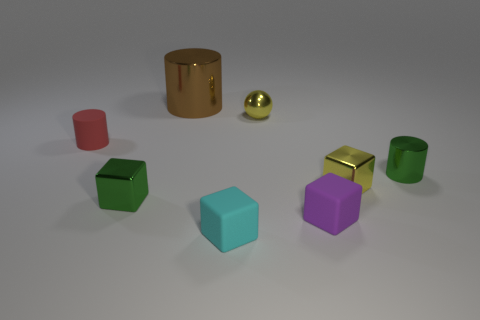Are there fewer tiny green things than green metal cylinders?
Make the answer very short. No. What is the color of the other tiny metallic object that is the same shape as the red object?
Provide a short and direct response. Green. There is a sphere that is the same material as the tiny green cylinder; what color is it?
Make the answer very short. Yellow. What number of green metallic cubes are the same size as the yellow metal block?
Keep it short and to the point. 1. What material is the small green block?
Offer a very short reply. Metal. Are there more cyan rubber cubes than small green shiny things?
Give a very brief answer. No. Is the red matte object the same shape as the big object?
Your response must be concise. Yes. Is there any other thing that has the same shape as the large thing?
Your answer should be compact. Yes. There is a small metallic block right of the small green metal block; is it the same color as the cube on the left side of the large metal cylinder?
Your answer should be compact. No. Is the number of brown metal cylinders to the right of the big shiny cylinder less than the number of cylinders in front of the small cyan object?
Provide a short and direct response. No. 